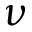<formula> <loc_0><loc_0><loc_500><loc_500>\nu</formula> 